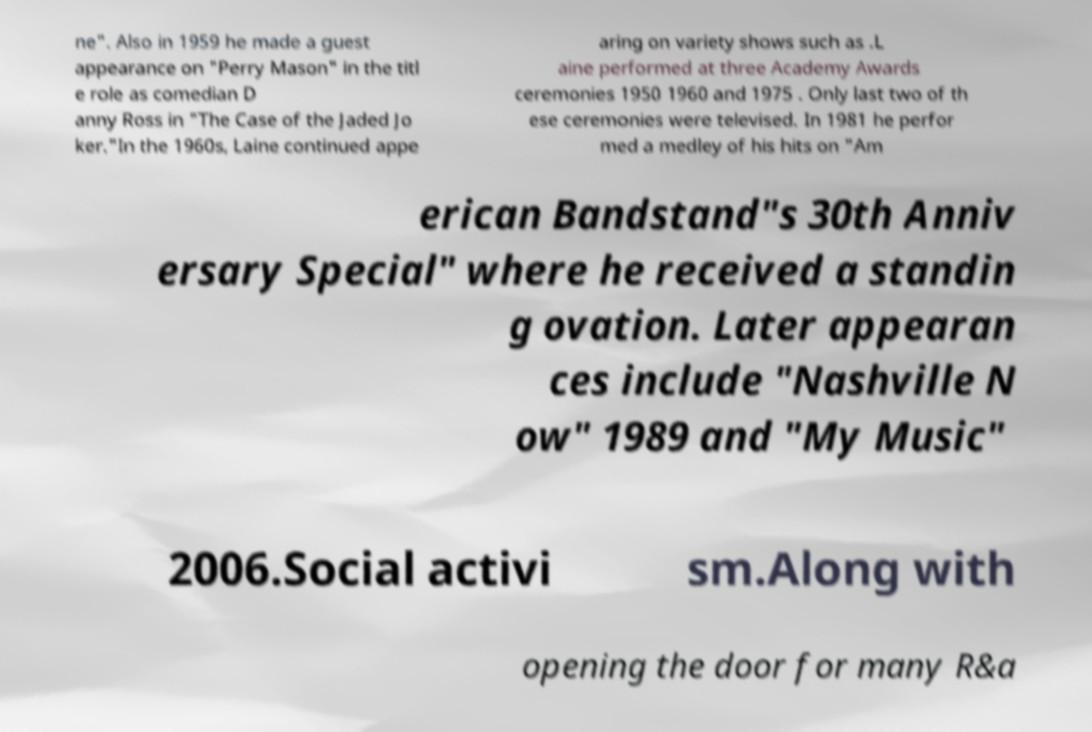Could you assist in decoding the text presented in this image and type it out clearly? ne". Also in 1959 he made a guest appearance on "Perry Mason" in the titl e role as comedian D anny Ross in "The Case of the Jaded Jo ker."In the 1960s, Laine continued appe aring on variety shows such as .L aine performed at three Academy Awards ceremonies 1950 1960 and 1975 . Only last two of th ese ceremonies were televised. In 1981 he perfor med a medley of his hits on "Am erican Bandstand"s 30th Anniv ersary Special" where he received a standin g ovation. Later appearan ces include "Nashville N ow" 1989 and "My Music" 2006.Social activi sm.Along with opening the door for many R&a 